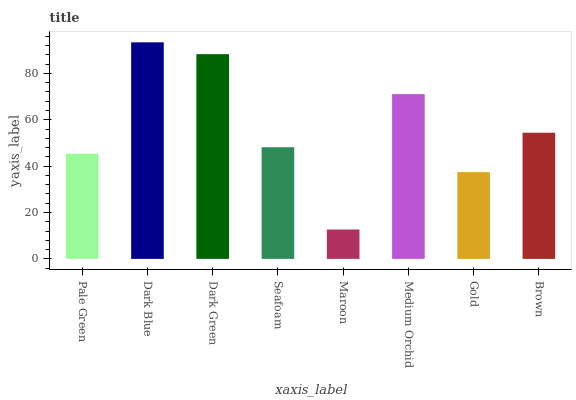Is Dark Green the minimum?
Answer yes or no. No. Is Dark Green the maximum?
Answer yes or no. No. Is Dark Blue greater than Dark Green?
Answer yes or no. Yes. Is Dark Green less than Dark Blue?
Answer yes or no. Yes. Is Dark Green greater than Dark Blue?
Answer yes or no. No. Is Dark Blue less than Dark Green?
Answer yes or no. No. Is Brown the high median?
Answer yes or no. Yes. Is Seafoam the low median?
Answer yes or no. Yes. Is Medium Orchid the high median?
Answer yes or no. No. Is Brown the low median?
Answer yes or no. No. 